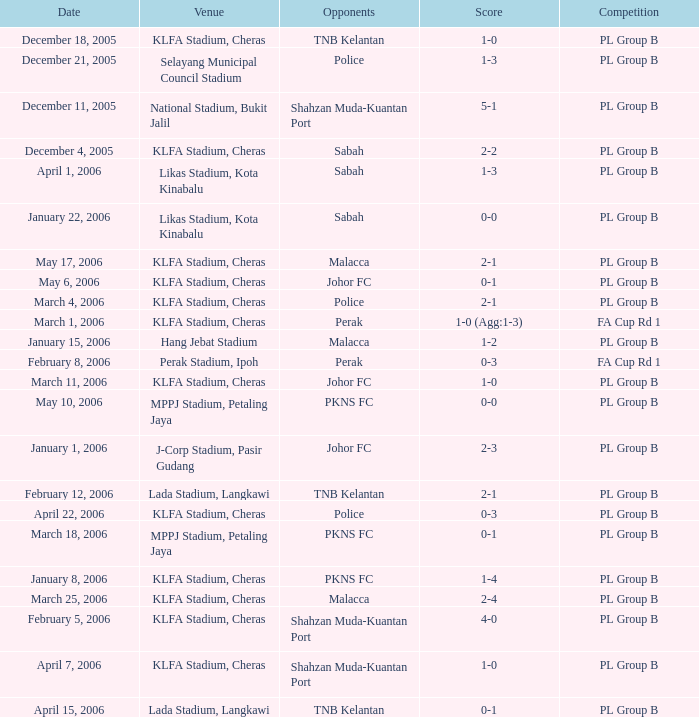In which game are the opponents pkns fc, and the score is currently 0-1? PL Group B. 